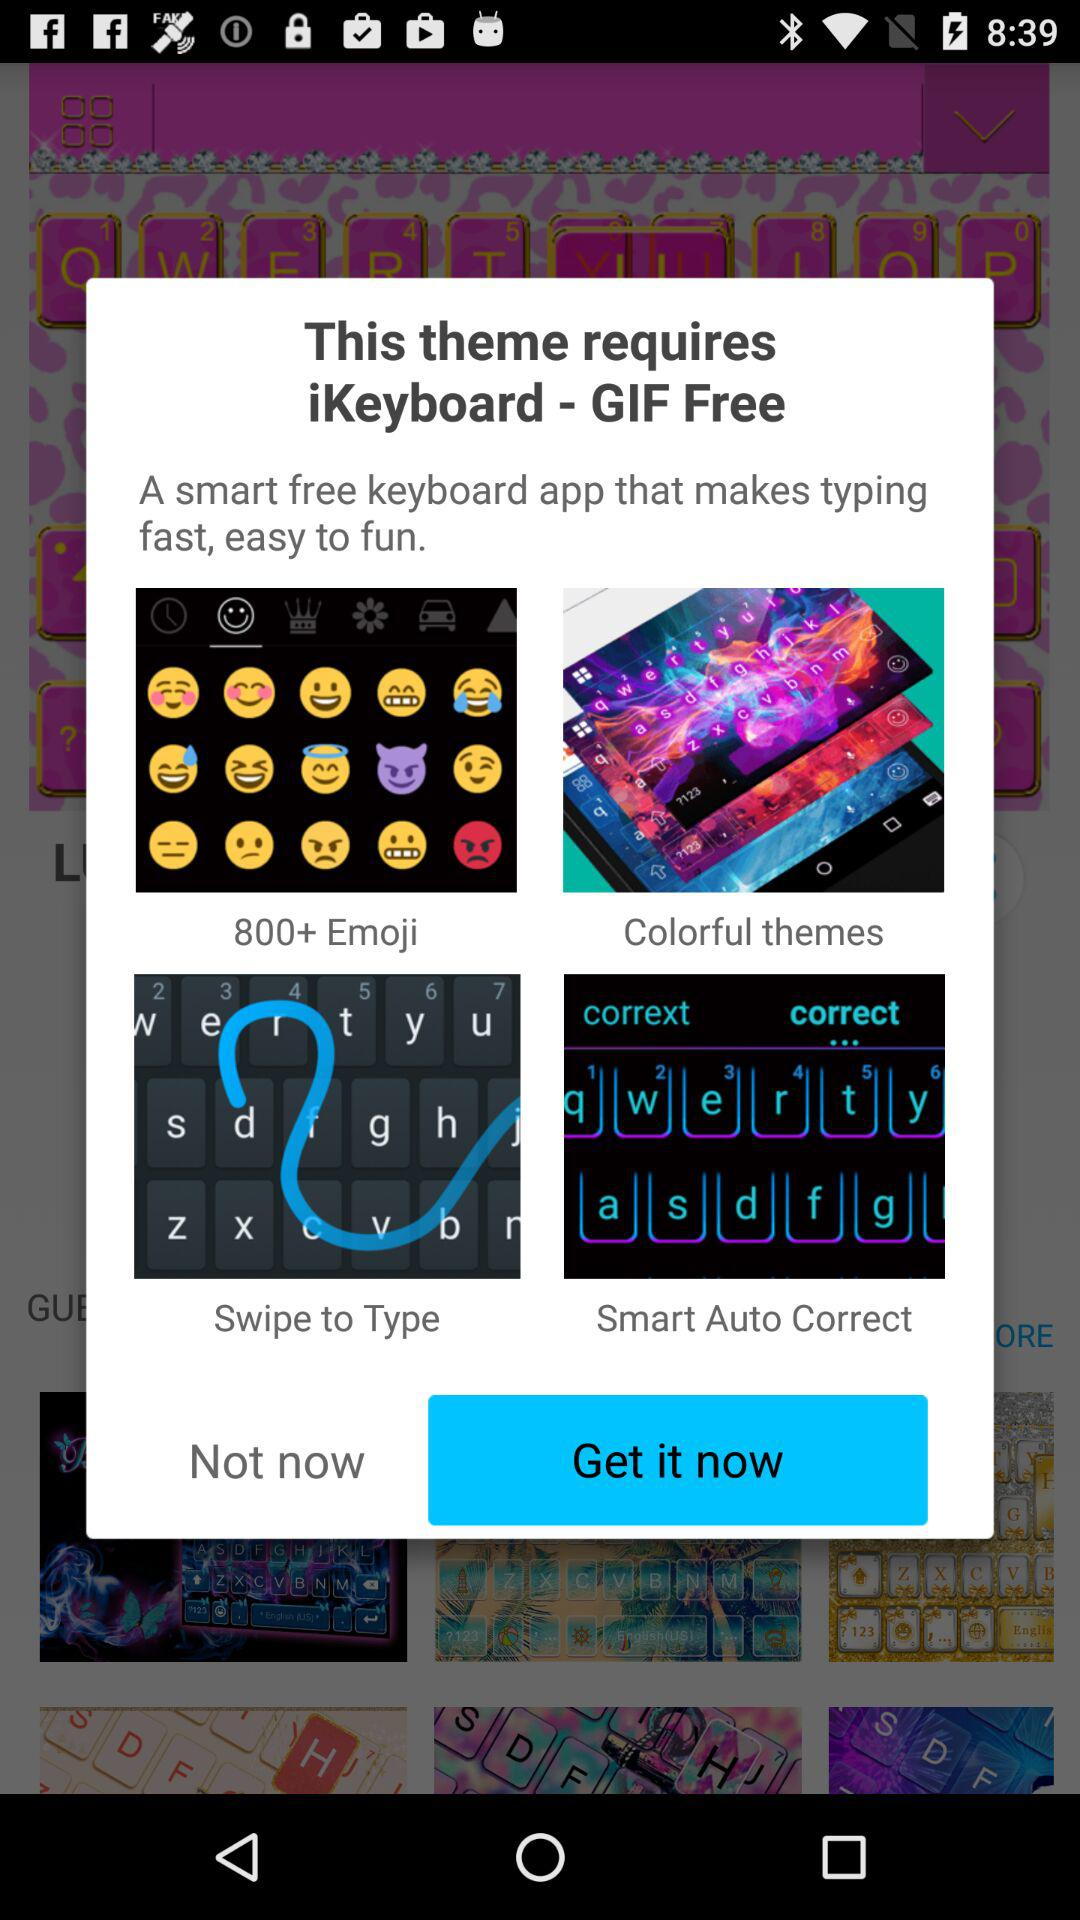How many features does this theme provide?
Answer the question using a single word or phrase. 4 